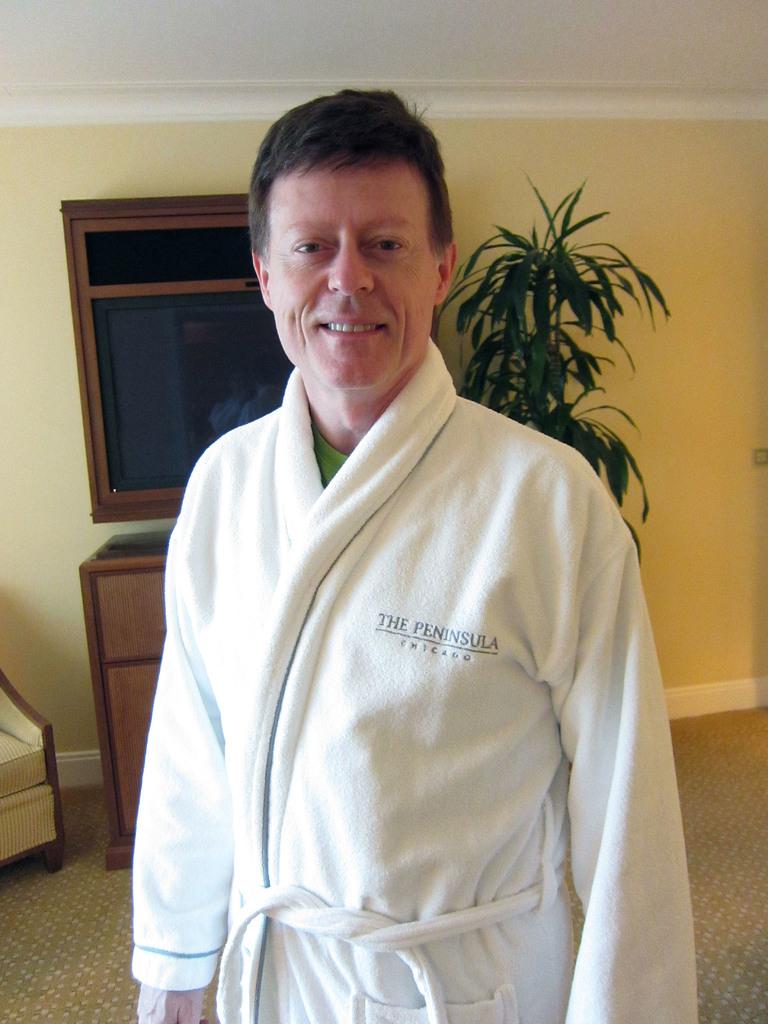What's the name of the resort?
Provide a succinct answer. The peninsula. 